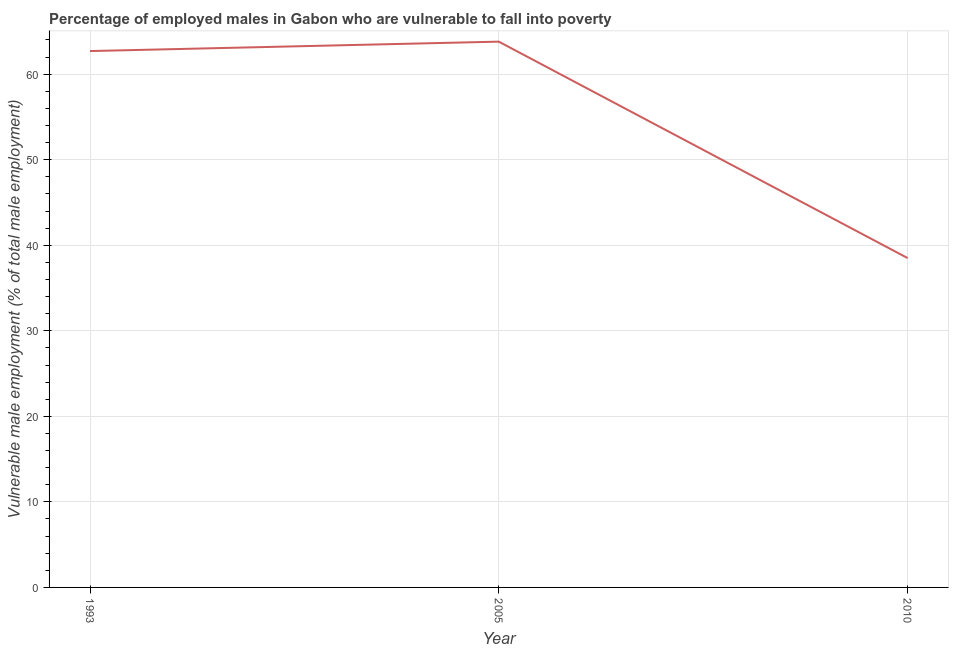What is the percentage of employed males who are vulnerable to fall into poverty in 2005?
Keep it short and to the point. 63.8. Across all years, what is the maximum percentage of employed males who are vulnerable to fall into poverty?
Your answer should be compact. 63.8. Across all years, what is the minimum percentage of employed males who are vulnerable to fall into poverty?
Provide a succinct answer. 38.5. What is the sum of the percentage of employed males who are vulnerable to fall into poverty?
Your answer should be compact. 165. What is the difference between the percentage of employed males who are vulnerable to fall into poverty in 2005 and 2010?
Ensure brevity in your answer.  25.3. What is the average percentage of employed males who are vulnerable to fall into poverty per year?
Give a very brief answer. 55. What is the median percentage of employed males who are vulnerable to fall into poverty?
Provide a short and direct response. 62.7. In how many years, is the percentage of employed males who are vulnerable to fall into poverty greater than 60 %?
Your response must be concise. 2. What is the ratio of the percentage of employed males who are vulnerable to fall into poverty in 2005 to that in 2010?
Give a very brief answer. 1.66. Is the percentage of employed males who are vulnerable to fall into poverty in 1993 less than that in 2010?
Ensure brevity in your answer.  No. What is the difference between the highest and the second highest percentage of employed males who are vulnerable to fall into poverty?
Offer a terse response. 1.1. What is the difference between the highest and the lowest percentage of employed males who are vulnerable to fall into poverty?
Your response must be concise. 25.3. What is the difference between two consecutive major ticks on the Y-axis?
Make the answer very short. 10. Are the values on the major ticks of Y-axis written in scientific E-notation?
Provide a succinct answer. No. Does the graph contain any zero values?
Ensure brevity in your answer.  No. Does the graph contain grids?
Your answer should be compact. Yes. What is the title of the graph?
Offer a terse response. Percentage of employed males in Gabon who are vulnerable to fall into poverty. What is the label or title of the X-axis?
Provide a succinct answer. Year. What is the label or title of the Y-axis?
Offer a very short reply. Vulnerable male employment (% of total male employment). What is the Vulnerable male employment (% of total male employment) of 1993?
Offer a terse response. 62.7. What is the Vulnerable male employment (% of total male employment) of 2005?
Make the answer very short. 63.8. What is the Vulnerable male employment (% of total male employment) of 2010?
Offer a terse response. 38.5. What is the difference between the Vulnerable male employment (% of total male employment) in 1993 and 2010?
Your response must be concise. 24.2. What is the difference between the Vulnerable male employment (% of total male employment) in 2005 and 2010?
Ensure brevity in your answer.  25.3. What is the ratio of the Vulnerable male employment (% of total male employment) in 1993 to that in 2005?
Provide a succinct answer. 0.98. What is the ratio of the Vulnerable male employment (% of total male employment) in 1993 to that in 2010?
Your response must be concise. 1.63. What is the ratio of the Vulnerable male employment (% of total male employment) in 2005 to that in 2010?
Give a very brief answer. 1.66. 